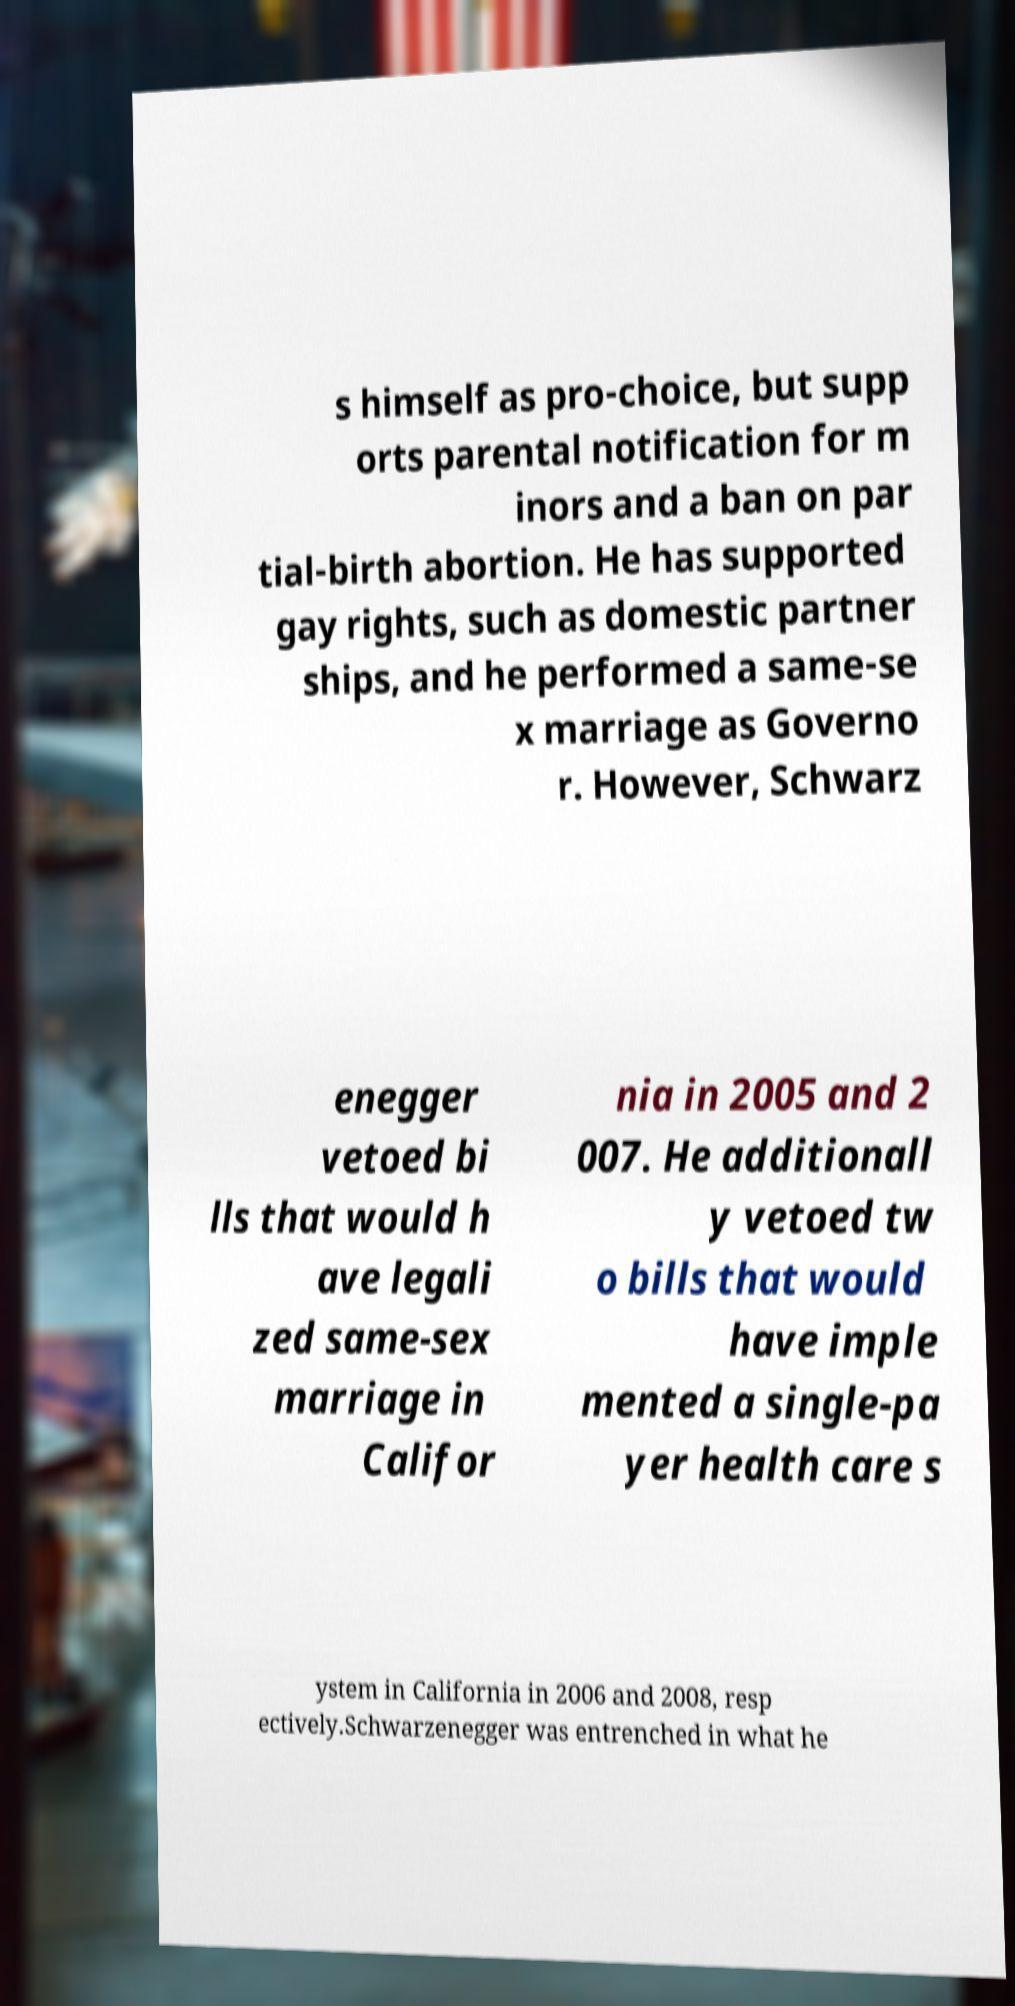Can you accurately transcribe the text from the provided image for me? s himself as pro-choice, but supp orts parental notification for m inors and a ban on par tial-birth abortion. He has supported gay rights, such as domestic partner ships, and he performed a same-se x marriage as Governo r. However, Schwarz enegger vetoed bi lls that would h ave legali zed same-sex marriage in Califor nia in 2005 and 2 007. He additionall y vetoed tw o bills that would have imple mented a single-pa yer health care s ystem in California in 2006 and 2008, resp ectively.Schwarzenegger was entrenched in what he 